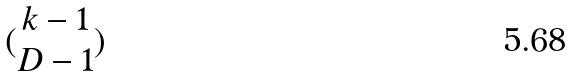<formula> <loc_0><loc_0><loc_500><loc_500>( \begin{matrix} k - 1 \\ D - 1 \end{matrix} )</formula> 